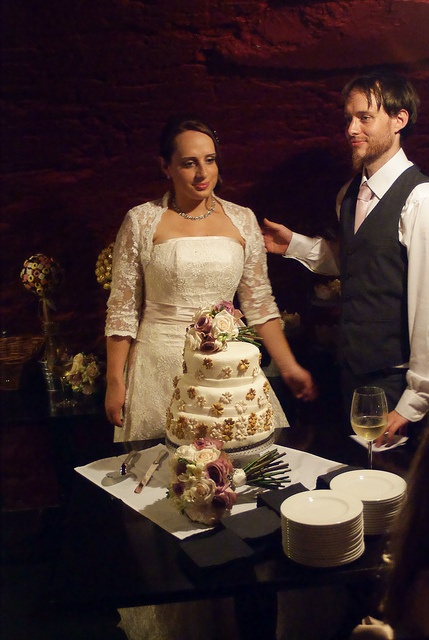Describe the objects in this image and their specific colors. I can see dining table in black, tan, gray, and maroon tones, people in black, tan, and gray tones, people in black, maroon, tan, and ivory tones, cake in black, tan, olive, and brown tones, and wine glass in black, maroon, and tan tones in this image. 